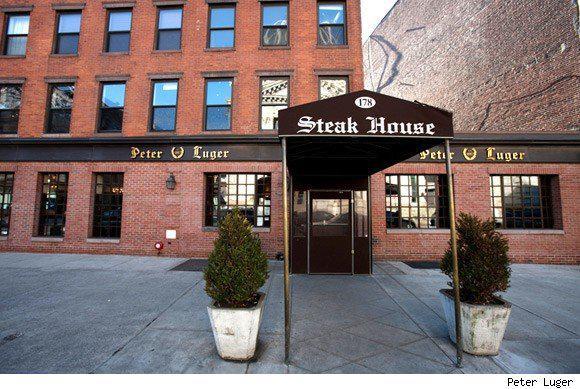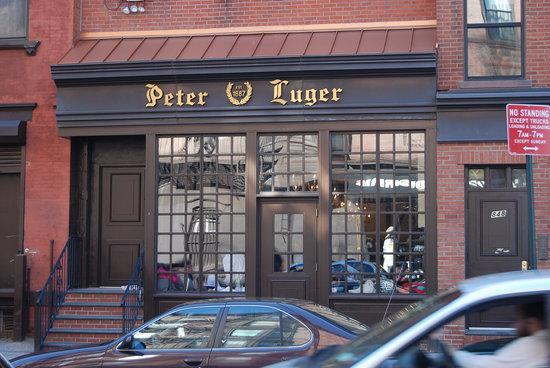The first image is the image on the left, the second image is the image on the right. Examine the images to the left and right. Is the description "There is a front awning in the left image." accurate? Answer yes or no. Yes. The first image is the image on the left, the second image is the image on the right. Analyze the images presented: Is the assertion "The right image shows at least one person in front of a black roof that extends out from a red brick building." valid? Answer yes or no. No. 